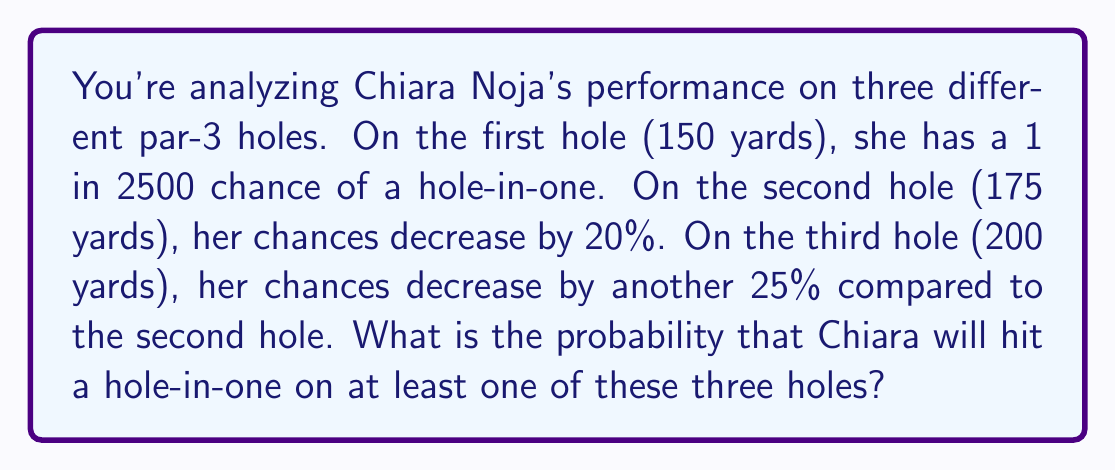Teach me how to tackle this problem. Let's approach this step-by-step:

1) First, let's calculate the probabilities for each hole:
   Hole 1 (150 yards): $p_1 = \frac{1}{2500} = 0.0004$
   Hole 2 (175 yards): $p_2 = 0.0004 \times 0.8 = 0.00032$
   Hole 3 (200 yards): $p_3 = 0.00032 \times 0.75 = 0.00024$

2) To find the probability of hitting at least one hole-in-one, we can calculate the probability of not hitting any hole-in-one and subtract it from 1.

3) The probability of not hitting a hole-in-one on all three holes is:
   $$(1-p_1) \times (1-p_2) \times (1-p_3)$$

4) Let's calculate this:
   $$(1-0.0004) \times (1-0.00032) \times (1-0.00024)$$
   $$= 0.9996 \times 0.99968 \times 0.99976$$
   $$= 0.99904096$$

5) Therefore, the probability of hitting at least one hole-in-one is:
   $$1 - 0.99904096 = 0.00095904$$

6) This can be expressed as a percentage:
   $$0.00095904 \times 100\% = 0.095904\%$$
Answer: $0.095904\%$ 